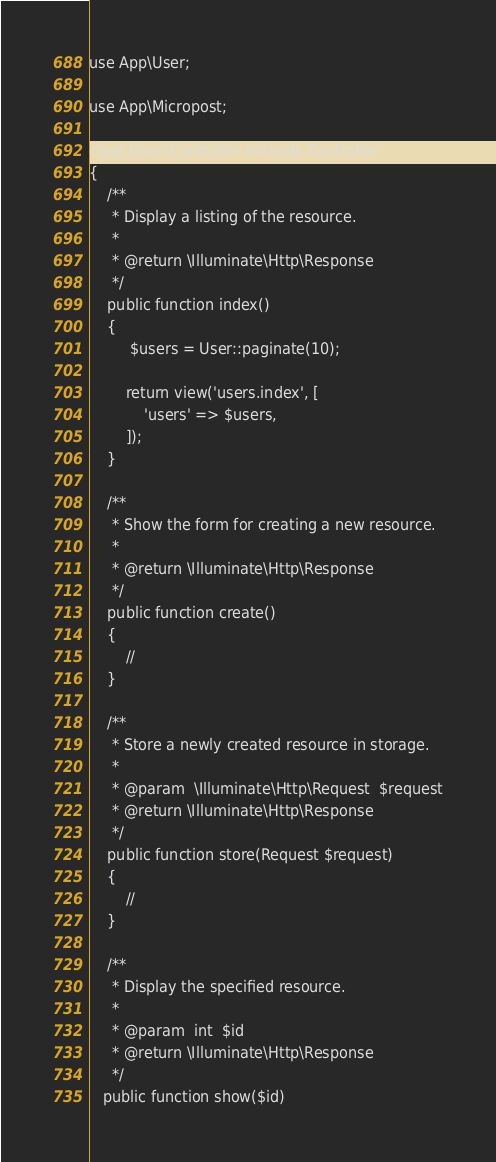<code> <loc_0><loc_0><loc_500><loc_500><_PHP_>
use App\User;

use App\Micropost;

class UsersController extends Controller
{
    /**
     * Display a listing of the resource.
     *
     * @return \Illuminate\Http\Response
     */
    public function index()
    {
         $users = User::paginate(10);
        
        return view('users.index', [
            'users' => $users,
        ]);
    }

    /**
     * Show the form for creating a new resource.
     *
     * @return \Illuminate\Http\Response
     */
    public function create()
    {
        //
    }

    /**
     * Store a newly created resource in storage.
     *
     * @param  \Illuminate\Http\Request  $request
     * @return \Illuminate\Http\Response
     */
    public function store(Request $request)
    {
        //
    }

    /**
     * Display the specified resource.
     *
     * @param  int  $id
     * @return \Illuminate\Http\Response
     */
   public function show($id)</code> 